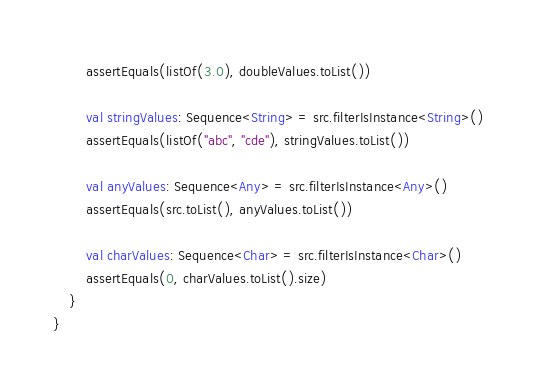Convert code to text. <code><loc_0><loc_0><loc_500><loc_500><_Kotlin_>        assertEquals(listOf(3.0), doubleValues.toList())

        val stringValues: Sequence<String> = src.filterIsInstance<String>()
        assertEquals(listOf("abc", "cde"), stringValues.toList())

        val anyValues: Sequence<Any> = src.filterIsInstance<Any>()
        assertEquals(src.toList(), anyValues.toList())

        val charValues: Sequence<Char> = src.filterIsInstance<Char>()
        assertEquals(0, charValues.toList().size)
    }
}
</code> 